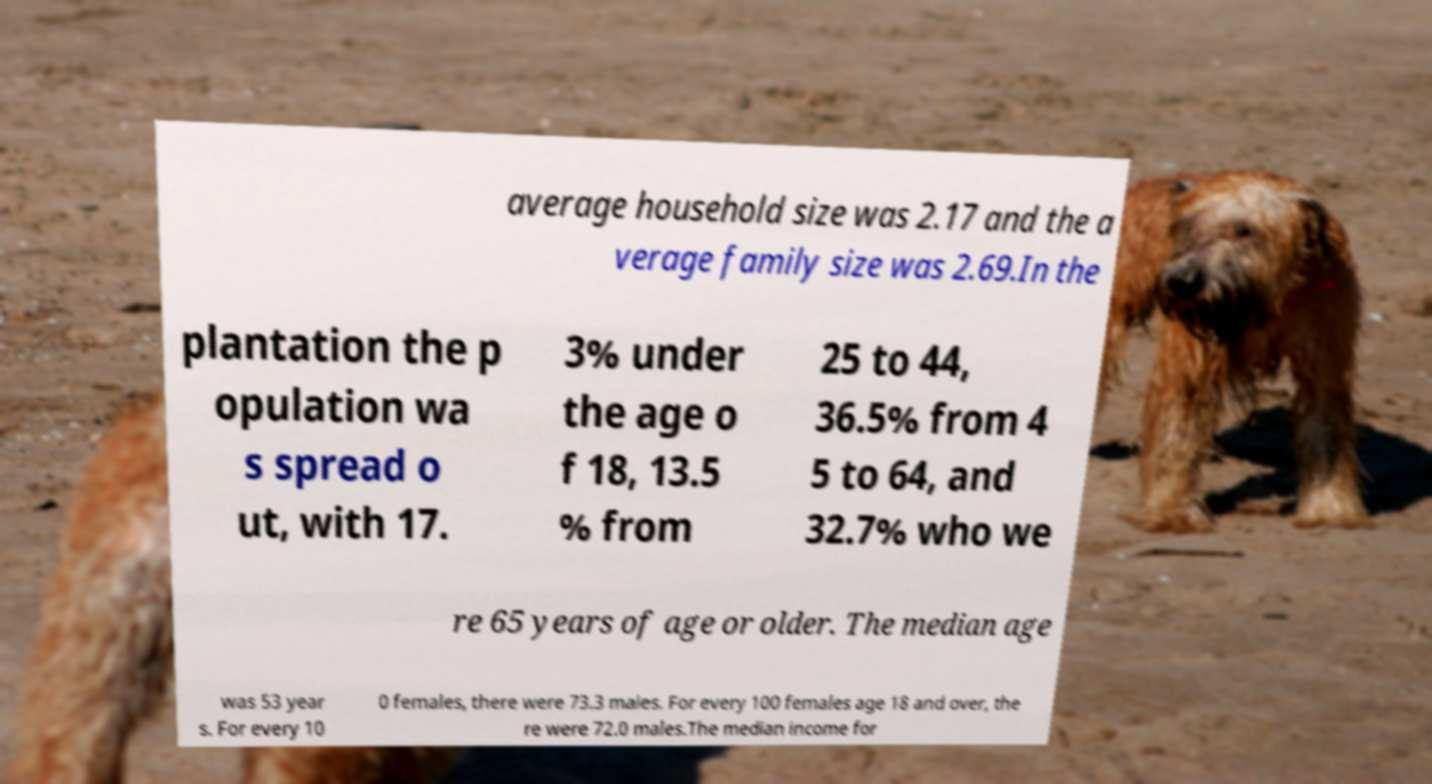I need the written content from this picture converted into text. Can you do that? average household size was 2.17 and the a verage family size was 2.69.In the plantation the p opulation wa s spread o ut, with 17. 3% under the age o f 18, 13.5 % from 25 to 44, 36.5% from 4 5 to 64, and 32.7% who we re 65 years of age or older. The median age was 53 year s. For every 10 0 females, there were 73.3 males. For every 100 females age 18 and over, the re were 72.0 males.The median income for 